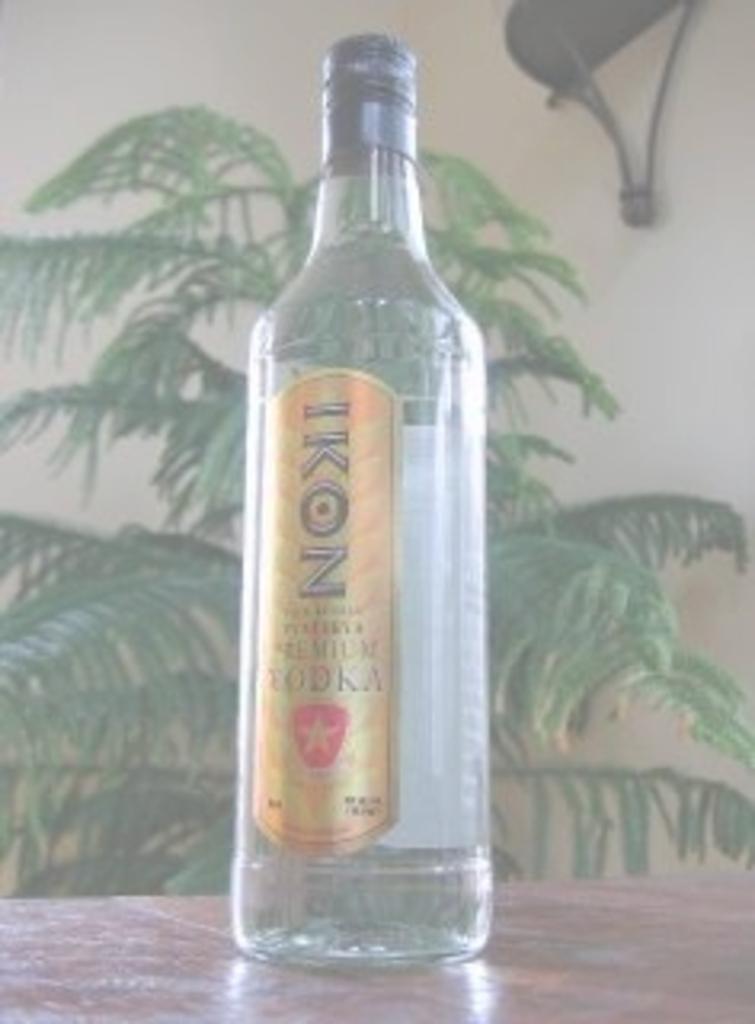Can you describe this image briefly? In this picture we can see a bottle empty placed on table and in background we can see wall, tree. 